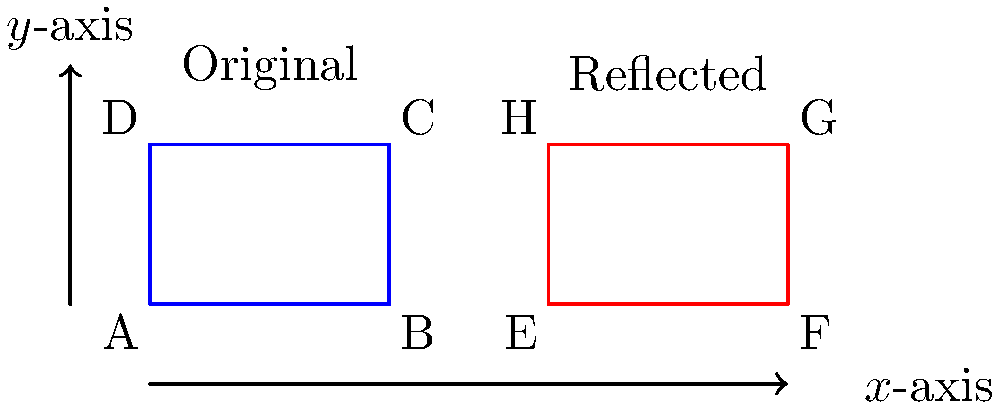In the figure above, a quadrilateral ABCD representing an "atheist A" symbol is reflected across the x-axis to form quadrilateral EFGH. If the coordinates of point C are (3, 2), what are the coordinates of point G after the reflection? To solve this problem, we need to understand the principle of reflection across the x-axis:

1. When a point is reflected across the x-axis, its x-coordinate remains the same, but its y-coordinate changes sign.

2. The coordinates of point C are given as (3, 2).

3. Point G is the reflection of point C across the x-axis.

4. To reflect point C:
   - The x-coordinate remains the same: 3
   - The y-coordinate changes sign: 2 becomes -2

5. Therefore, the coordinates of point G after reflection are (3, -2).

This reflection demonstrates how the "atheist A" symbol, often associated with Christopher Hitchens' advocacy for atheism, can be transformed while maintaining its shape, much like how Hitchens' ideas continue to be reflected and discussed in various contexts.
Answer: (3, -2) 